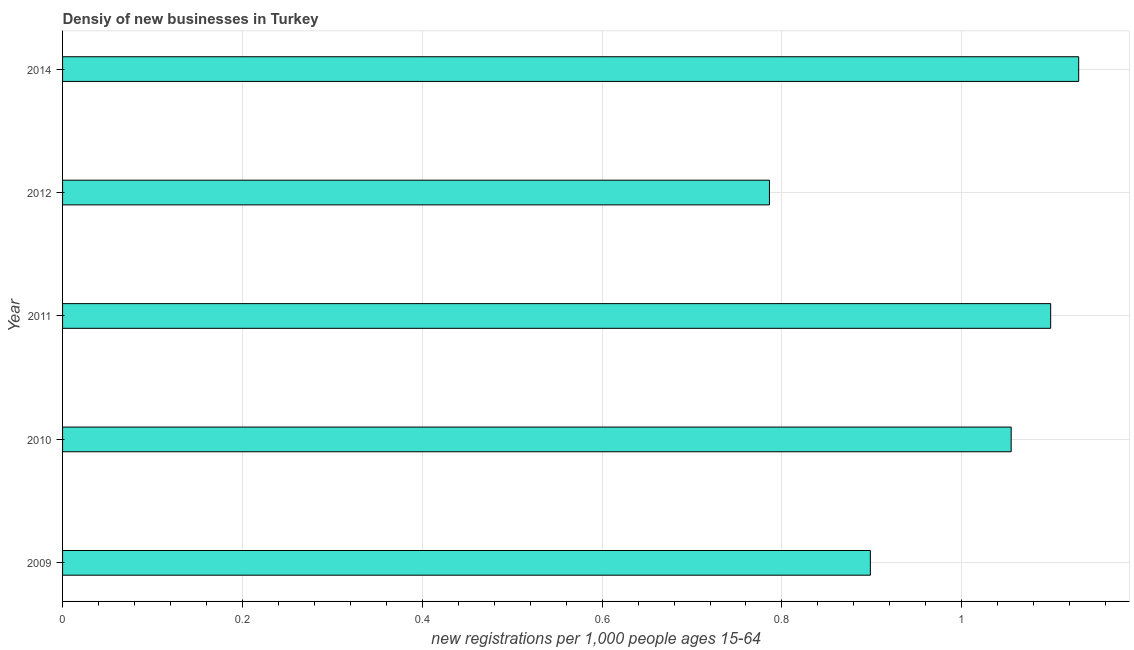Does the graph contain grids?
Offer a terse response. Yes. What is the title of the graph?
Your answer should be very brief. Densiy of new businesses in Turkey. What is the label or title of the X-axis?
Your response must be concise. New registrations per 1,0 people ages 15-64. What is the density of new business in 2011?
Give a very brief answer. 1.1. Across all years, what is the maximum density of new business?
Provide a succinct answer. 1.13. Across all years, what is the minimum density of new business?
Provide a succinct answer. 0.79. What is the sum of the density of new business?
Ensure brevity in your answer.  4.97. What is the difference between the density of new business in 2010 and 2011?
Give a very brief answer. -0.04. What is the average density of new business per year?
Offer a very short reply. 0.99. What is the median density of new business?
Make the answer very short. 1.05. Do a majority of the years between 2011 and 2012 (inclusive) have density of new business greater than 0.52 ?
Your answer should be compact. Yes. What is the ratio of the density of new business in 2010 to that in 2011?
Your answer should be compact. 0.96. What is the difference between the highest and the second highest density of new business?
Your response must be concise. 0.03. What is the difference between the highest and the lowest density of new business?
Provide a short and direct response. 0.34. In how many years, is the density of new business greater than the average density of new business taken over all years?
Provide a succinct answer. 3. What is the difference between two consecutive major ticks on the X-axis?
Provide a succinct answer. 0.2. Are the values on the major ticks of X-axis written in scientific E-notation?
Offer a very short reply. No. What is the new registrations per 1,000 people ages 15-64 in 2009?
Your answer should be compact. 0.9. What is the new registrations per 1,000 people ages 15-64 in 2010?
Ensure brevity in your answer.  1.05. What is the new registrations per 1,000 people ages 15-64 in 2011?
Keep it short and to the point. 1.1. What is the new registrations per 1,000 people ages 15-64 of 2012?
Offer a very short reply. 0.79. What is the new registrations per 1,000 people ages 15-64 of 2014?
Provide a short and direct response. 1.13. What is the difference between the new registrations per 1,000 people ages 15-64 in 2009 and 2010?
Provide a short and direct response. -0.16. What is the difference between the new registrations per 1,000 people ages 15-64 in 2009 and 2011?
Your answer should be very brief. -0.2. What is the difference between the new registrations per 1,000 people ages 15-64 in 2009 and 2012?
Your answer should be very brief. 0.11. What is the difference between the new registrations per 1,000 people ages 15-64 in 2009 and 2014?
Give a very brief answer. -0.23. What is the difference between the new registrations per 1,000 people ages 15-64 in 2010 and 2011?
Make the answer very short. -0.04. What is the difference between the new registrations per 1,000 people ages 15-64 in 2010 and 2012?
Your response must be concise. 0.27. What is the difference between the new registrations per 1,000 people ages 15-64 in 2010 and 2014?
Your response must be concise. -0.08. What is the difference between the new registrations per 1,000 people ages 15-64 in 2011 and 2012?
Your answer should be compact. 0.31. What is the difference between the new registrations per 1,000 people ages 15-64 in 2011 and 2014?
Offer a terse response. -0.03. What is the difference between the new registrations per 1,000 people ages 15-64 in 2012 and 2014?
Your answer should be compact. -0.34. What is the ratio of the new registrations per 1,000 people ages 15-64 in 2009 to that in 2010?
Your answer should be compact. 0.85. What is the ratio of the new registrations per 1,000 people ages 15-64 in 2009 to that in 2011?
Your answer should be very brief. 0.82. What is the ratio of the new registrations per 1,000 people ages 15-64 in 2009 to that in 2012?
Keep it short and to the point. 1.14. What is the ratio of the new registrations per 1,000 people ages 15-64 in 2009 to that in 2014?
Provide a short and direct response. 0.8. What is the ratio of the new registrations per 1,000 people ages 15-64 in 2010 to that in 2011?
Provide a succinct answer. 0.96. What is the ratio of the new registrations per 1,000 people ages 15-64 in 2010 to that in 2012?
Offer a terse response. 1.34. What is the ratio of the new registrations per 1,000 people ages 15-64 in 2010 to that in 2014?
Keep it short and to the point. 0.93. What is the ratio of the new registrations per 1,000 people ages 15-64 in 2011 to that in 2012?
Your answer should be very brief. 1.4. What is the ratio of the new registrations per 1,000 people ages 15-64 in 2011 to that in 2014?
Give a very brief answer. 0.97. What is the ratio of the new registrations per 1,000 people ages 15-64 in 2012 to that in 2014?
Your answer should be very brief. 0.7. 